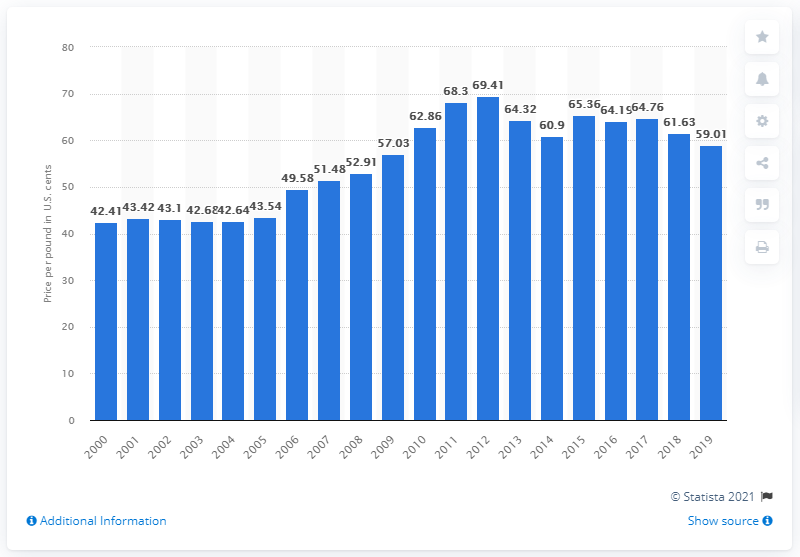Point out several critical features in this image. In 2019, the average retail price per pound of granulated sugar was 59.01 cents. 